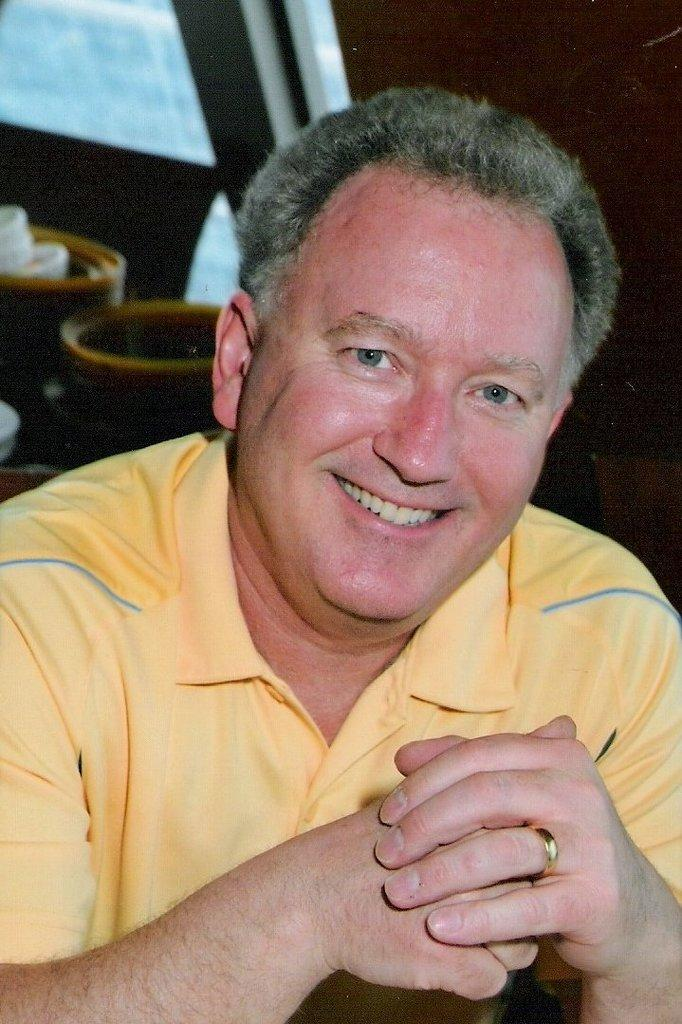What is the main subject of the image? There is a man in the image. What is the man doing in the image? The man is standing in the image. What is the man's facial expression in the image? The man is smiling in the image. Can you describe the background of the image? The background of the image is not clear enough to describe specific objects. What type of butter can be seen on the man's face in the image? There is no butter present on the man's face in the image. How many pears are visible on the ground near the man in the image? There are no pears visible in the image. 